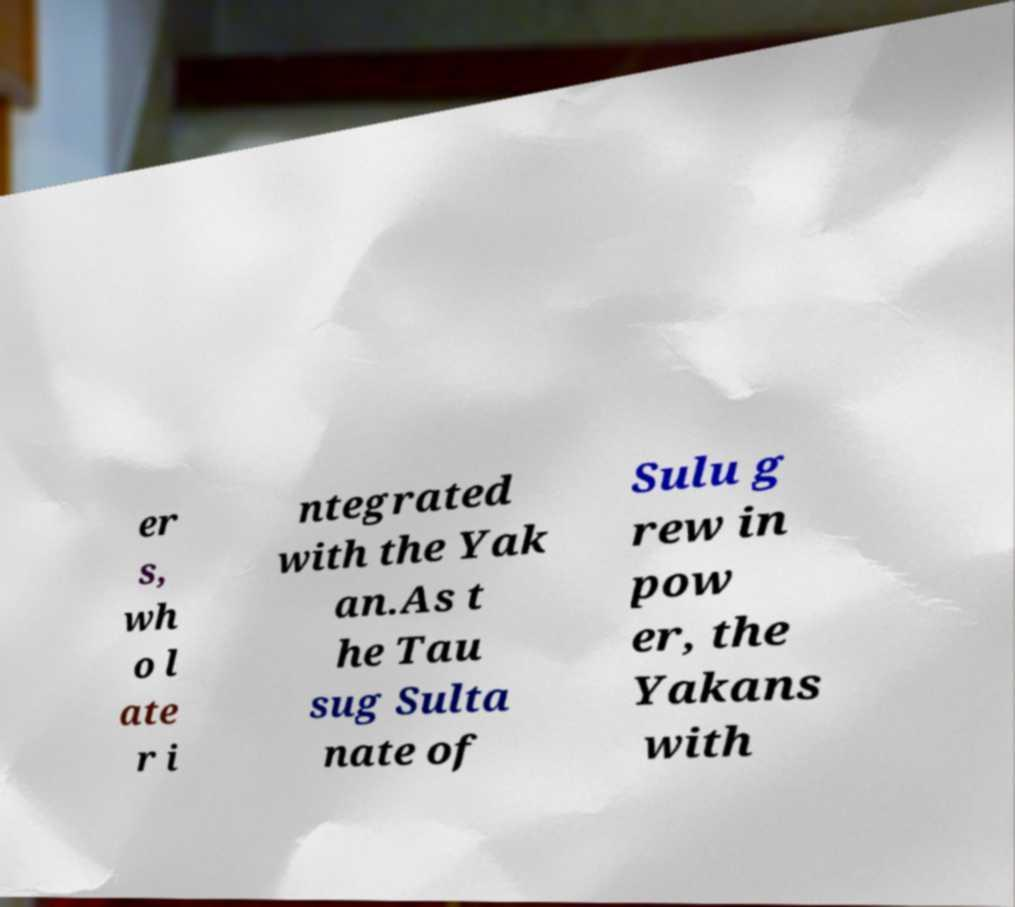Can you read and provide the text displayed in the image?This photo seems to have some interesting text. Can you extract and type it out for me? er s, wh o l ate r i ntegrated with the Yak an.As t he Tau sug Sulta nate of Sulu g rew in pow er, the Yakans with 